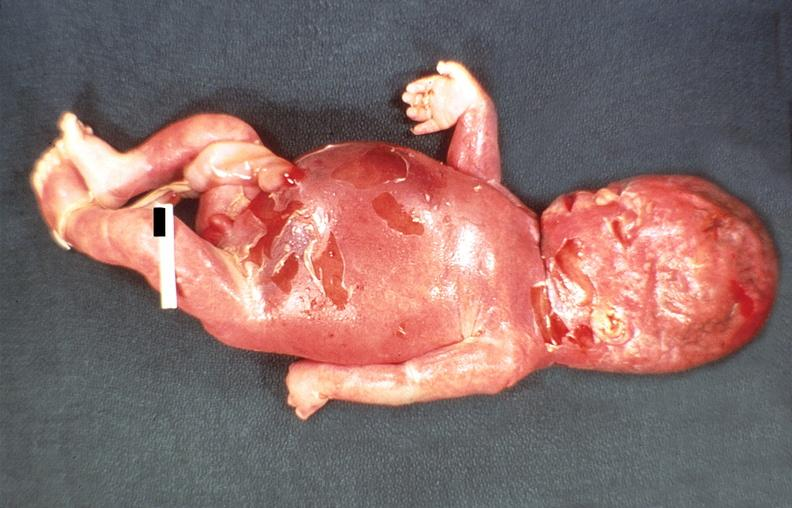does this image show hemolytic disease of newborn?
Answer the question using a single word or phrase. Yes 